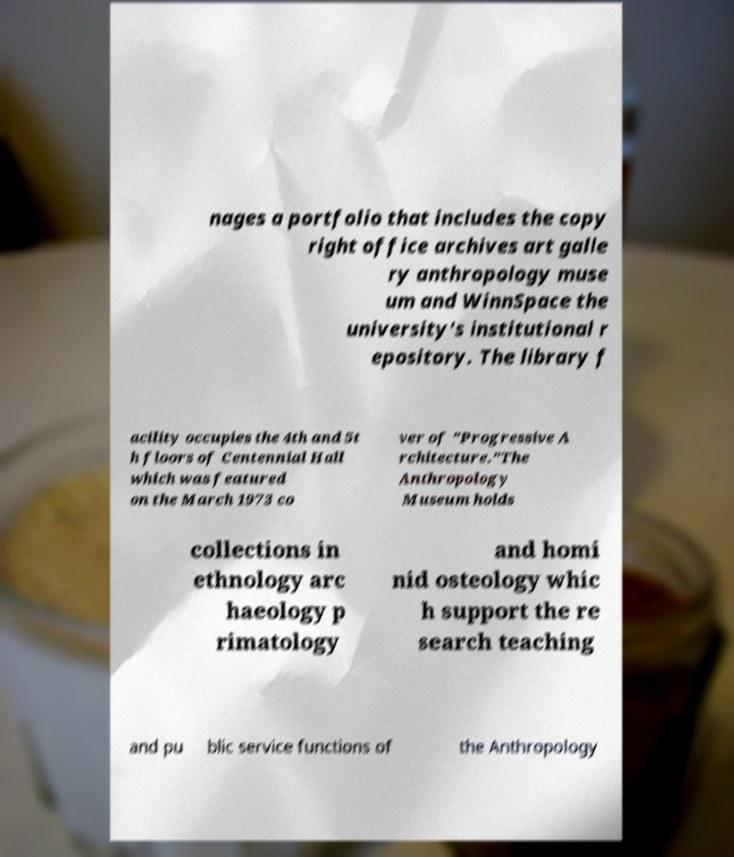Please read and relay the text visible in this image. What does it say? nages a portfolio that includes the copy right office archives art galle ry anthropology muse um and WinnSpace the university's institutional r epository. The library f acility occupies the 4th and 5t h floors of Centennial Hall which was featured on the March 1973 co ver of "Progressive A rchitecture."The Anthropology Museum holds collections in ethnology arc haeology p rimatology and homi nid osteology whic h support the re search teaching and pu blic service functions of the Anthropology 